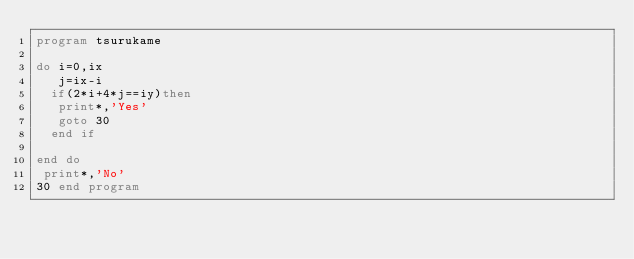<code> <loc_0><loc_0><loc_500><loc_500><_FORTRAN_>program tsurukame

do i=0,ix
   j=ix-i
  if(2*i+4*j==iy)then
   print*,'Yes'
   goto 30
  end if
 
end do
 print*,'No'
30 end program
</code> 